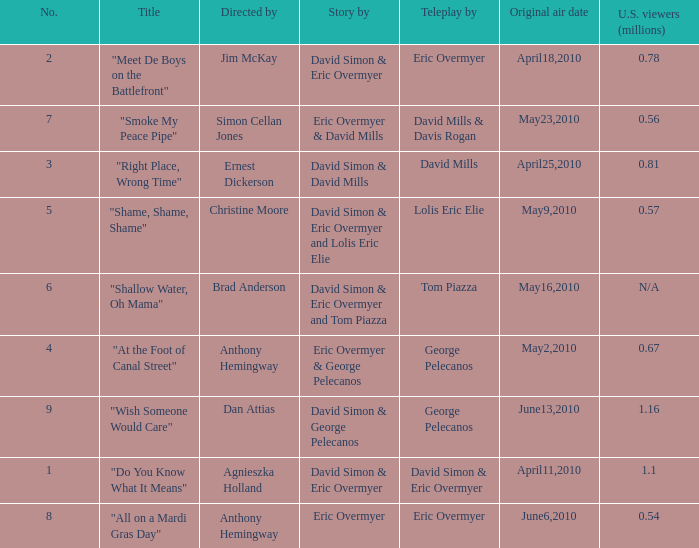Name the number for simon cellan jones 7.0. 